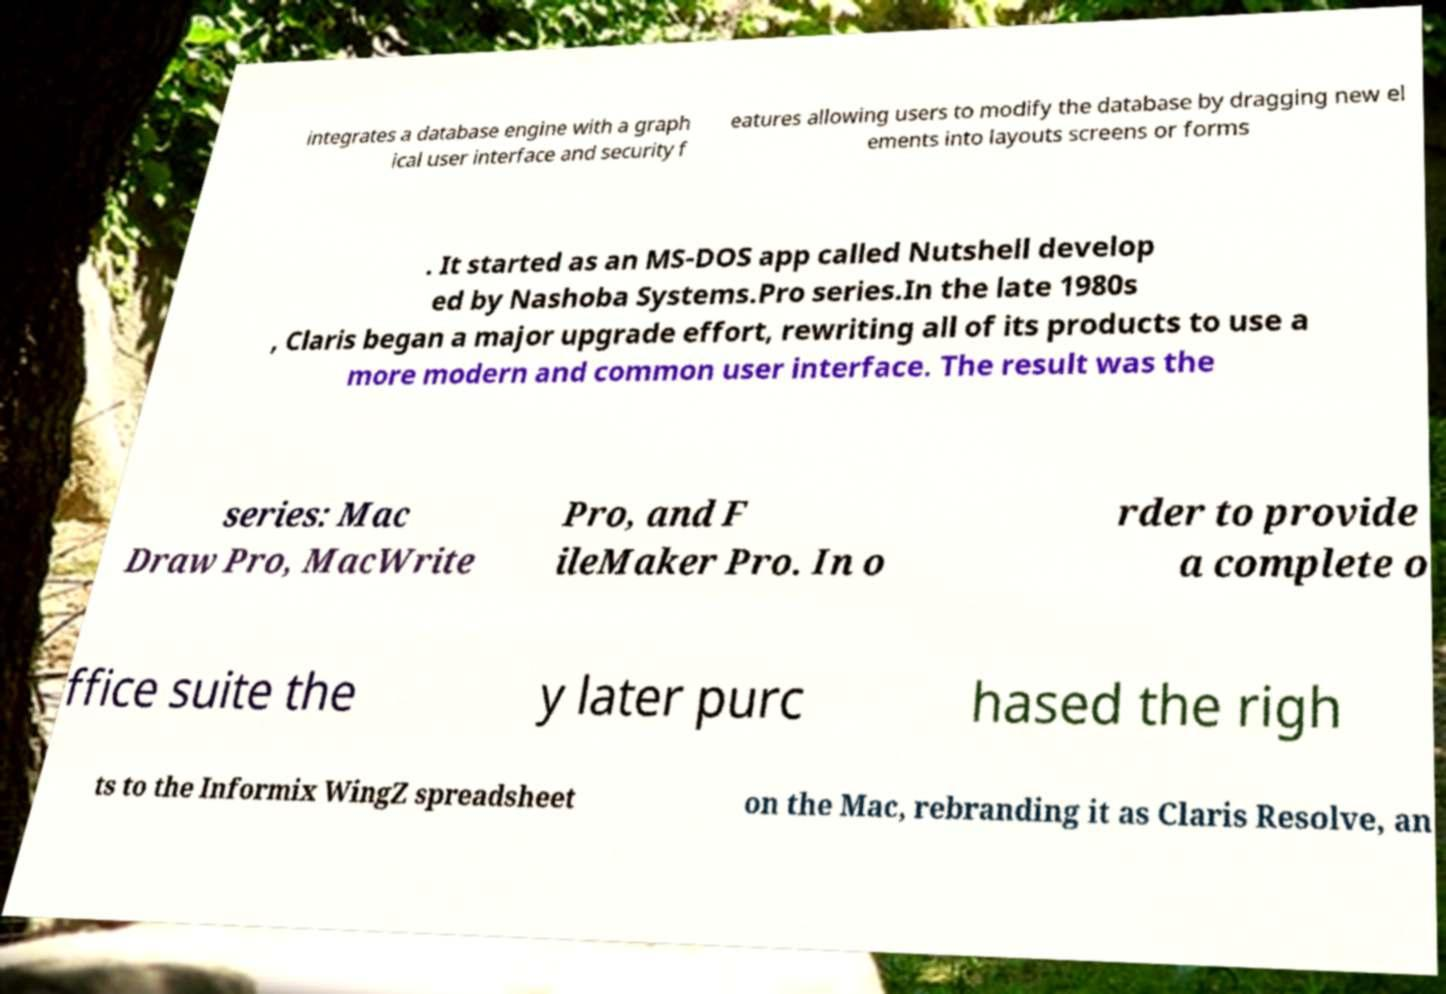Could you assist in decoding the text presented in this image and type it out clearly? integrates a database engine with a graph ical user interface and security f eatures allowing users to modify the database by dragging new el ements into layouts screens or forms . It started as an MS-DOS app called Nutshell develop ed by Nashoba Systems.Pro series.In the late 1980s , Claris began a major upgrade effort, rewriting all of its products to use a more modern and common user interface. The result was the series: Mac Draw Pro, MacWrite Pro, and F ileMaker Pro. In o rder to provide a complete o ffice suite the y later purc hased the righ ts to the Informix WingZ spreadsheet on the Mac, rebranding it as Claris Resolve, an 